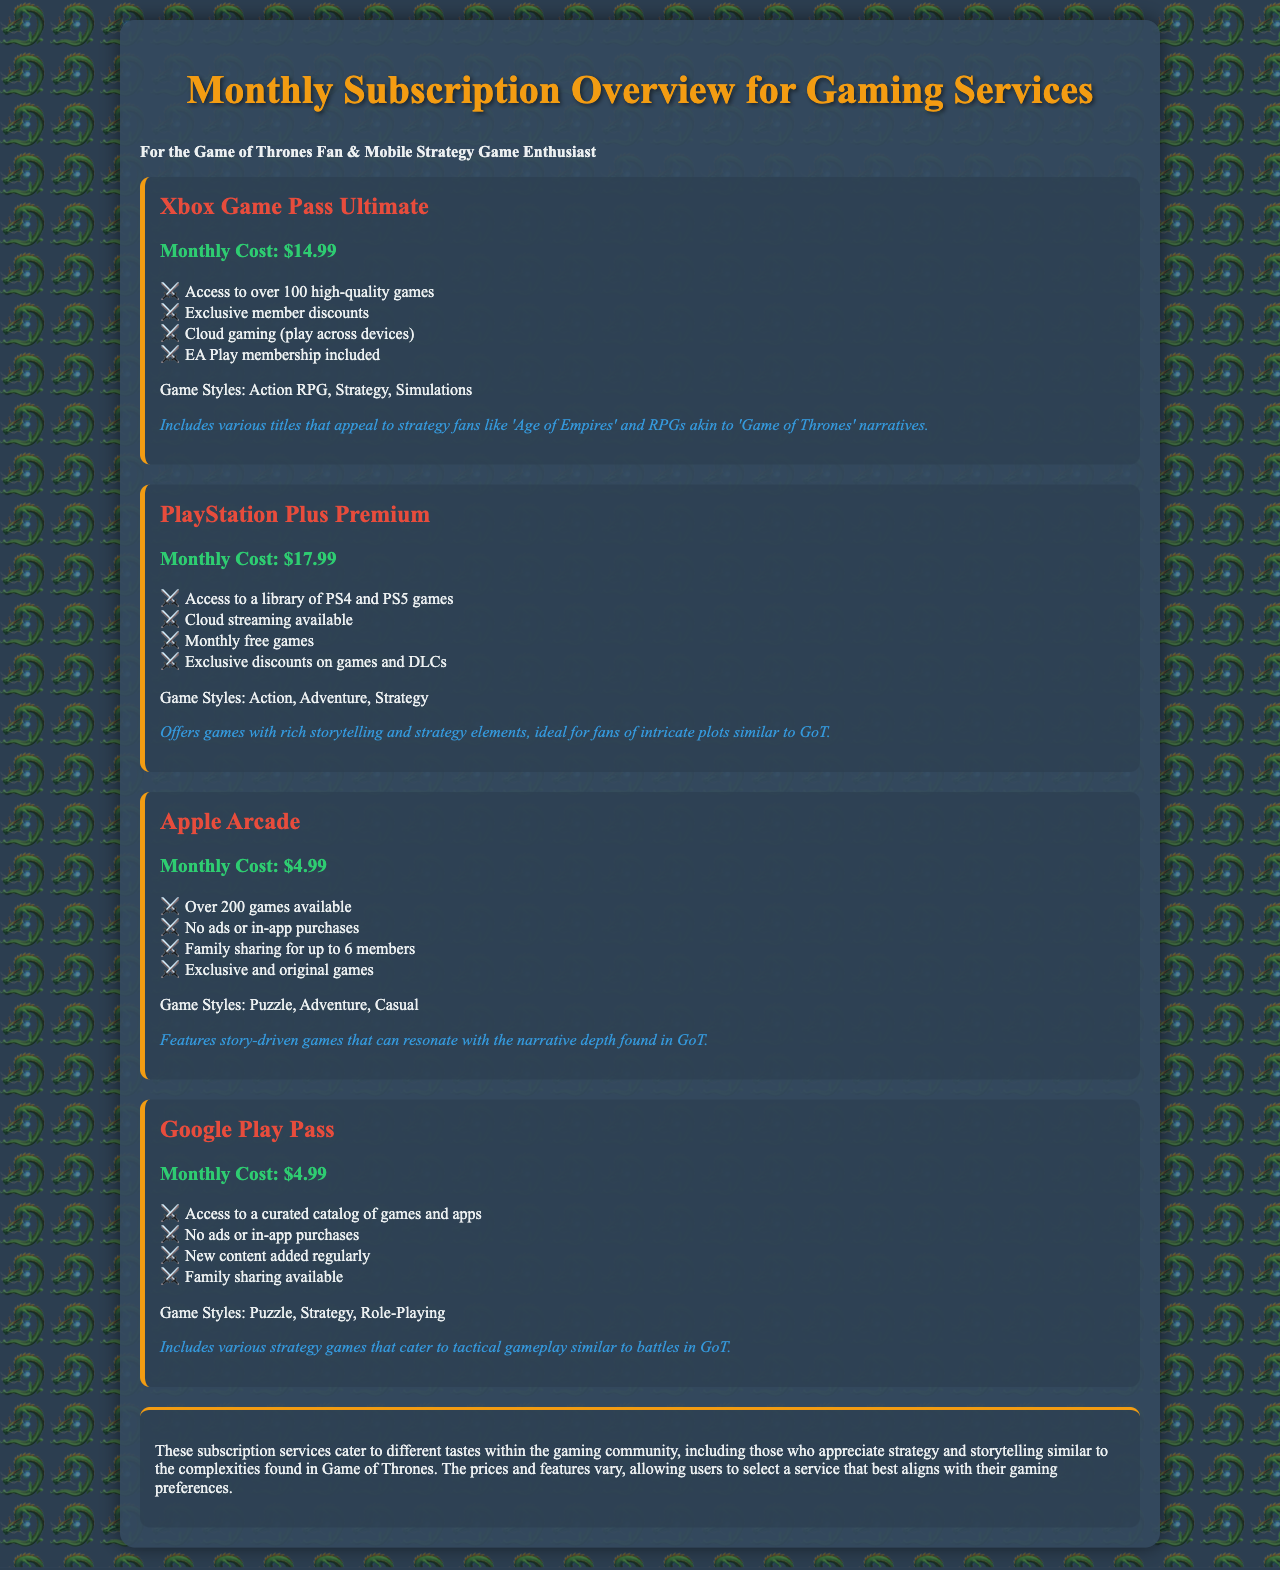What is the price of Xbox Game Pass Ultimate? The price of Xbox Game Pass Ultimate is mentioned as the Monthly Cost under the service details.
Answer: $14.99 Which subscription service includes EA Play membership? The inclusion of EA Play membership is specifically mentioned for Xbox Game Pass Ultimate.
Answer: Xbox Game Pass Ultimate What are the game styles available for PlayStation Plus Premium? The game styles are listed within the service description for PlayStation Plus Premium.
Answer: Action, Adventure, Strategy Which service offers family sharing for up to 6 members? The document states that Apple Arcade includes family sharing for up to 6 members under its features.
Answer: Apple Arcade How many games are available in Apple Arcade? The number of games provided for Apple Arcade is stated directly in the service details.
Answer: Over 200 games What is the monthly cost of Google Play Pass? The monthly cost for Google Play Pass is outlined in the service description.
Answer: $4.99 Why might a Game of Thrones fan choose PlayStation Plus Premium? The document notes that PlayStation Plus Premium offers games with rich storytelling and strategy elements, which may appeal to GoT fans.
Answer: Rich storytelling and strategy elements What common feature is provided by both Apple Arcade and Google Play Pass? Both subscription services are highlighted for having no ads or in-app purchases in their features.
Answer: No ads or in-app purchases What is the monthly cost of Apple Arcade? The document mentions the monthly cost of Apple Arcade directly in its description.
Answer: $4.99 